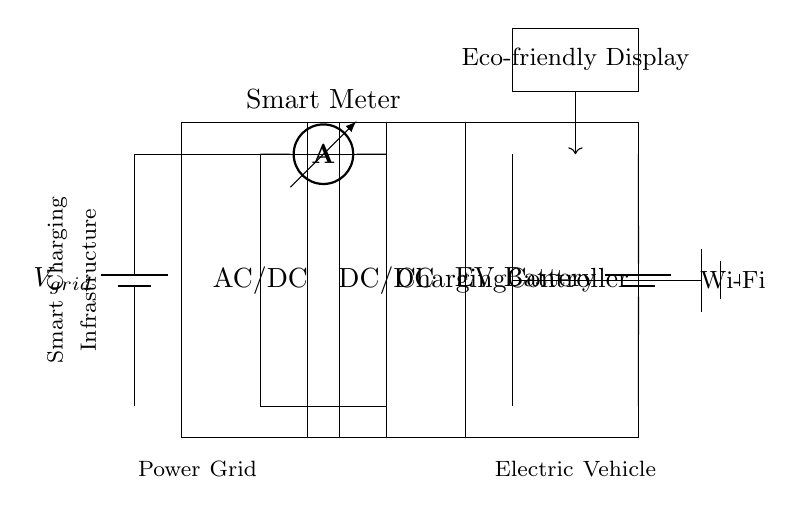What is the power source in this circuit? The power source in the circuit is labeled as V_grid, which represents the connection to the power grid.
Answer: V_grid What is the function of the AC/DC component? The AC/DC component is responsible for converting alternating current from the power grid to direct current that is suitable for charging electric vehicle batteries.
Answer: Converting AC to DC What component measures the current in the circuit? The component that measures current in the circuit is indicated as a smart meter, which is placed between the AC/DC and DC/DC converters.
Answer: Smart Meter What is the role of the charging controller? The charging controller regulates the voltage and current for the electric vehicle's battery, ensuring safe and efficient charging.
Answer: Regulation of charging How does the smart charging infrastructure connect to the internet? The connection is facilitated via a Wi-Fi symbol next to the charging controller, indicating wireless communication capabilities.
Answer: Wi-Fi What is displayed on the eco-friendly display? The eco-friendly display shows information related to the charging process and its impact, aiming to promote environmentally-friendly use of the technology.
Answer: Eco-friendly information Which component is responsible for converting DC voltage levels? The component responsible for converting DC voltage levels in the circuit is the DC/DC converter, which ensures the output voltage matches the requirements of the EV battery.
Answer: DC/DC Converter 